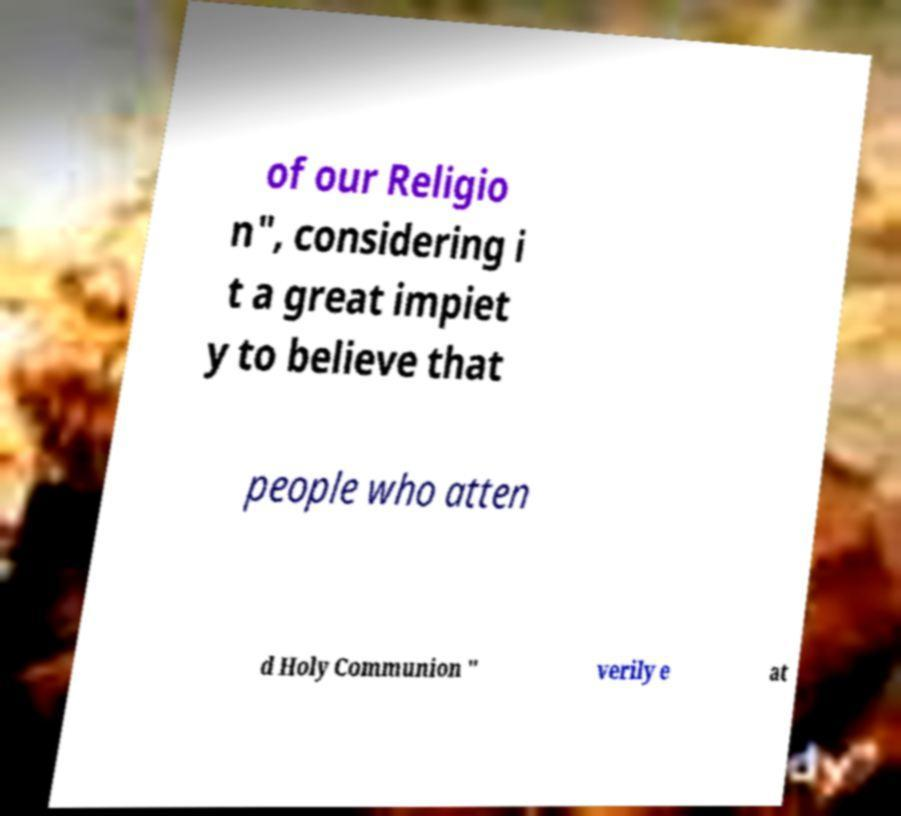Could you assist in decoding the text presented in this image and type it out clearly? of our Religio n", considering i t a great impiet y to believe that people who atten d Holy Communion " verily e at 